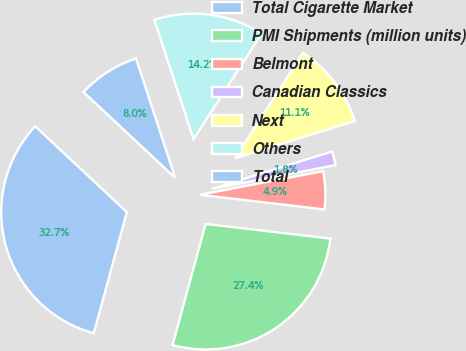<chart> <loc_0><loc_0><loc_500><loc_500><pie_chart><fcel>Total Cigarette Market<fcel>PMI Shipments (million units)<fcel>Belmont<fcel>Canadian Classics<fcel>Next<fcel>Others<fcel>Total<nl><fcel>32.74%<fcel>27.38%<fcel>4.88%<fcel>1.79%<fcel>11.07%<fcel>14.17%<fcel>7.98%<nl></chart> 